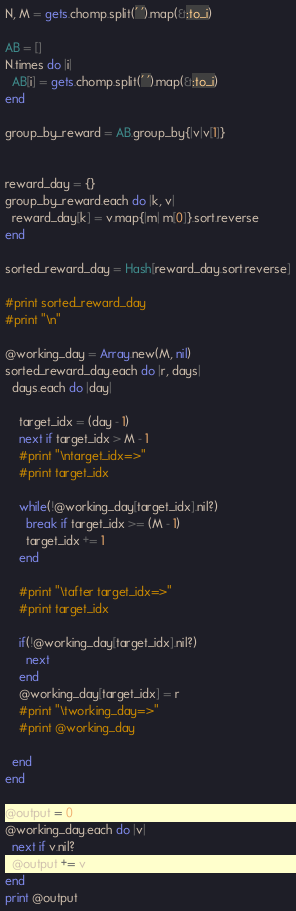Convert code to text. <code><loc_0><loc_0><loc_500><loc_500><_Ruby_>N, M = gets.chomp.split(' ').map(&:to_i)

AB = []
N.times do |i|
  AB[i] = gets.chomp.split(' ').map(&:to_i)
end

group_by_reward = AB.group_by{|v|v[1]}


reward_day = {}
group_by_reward.each do |k, v|
  reward_day[k] = v.map{|m| m[0]}.sort.reverse
end

sorted_reward_day = Hash[reward_day.sort.reverse]

#print sorted_reward_day
#print "\n"

@working_day = Array.new(M, nil)
sorted_reward_day.each do |r, days|
  days.each do |day|

    target_idx = (day - 1)
    next if target_idx > M - 1
    #print "\ntarget_idx=>"
    #print target_idx

    while(!@working_day[target_idx].nil?)
      break if target_idx >= (M - 1)
      target_idx += 1
    end

    #print "\tafter target_idx=>"
    #print target_idx

    if(!@working_day[target_idx].nil?)
      next
    end
    @working_day[target_idx] = r
    #print "\tworking_day=>"
    #print @working_day

  end
end

@output = 0
@working_day.each do |v|
  next if v.nil?
  @output += v
end
print @output
</code> 